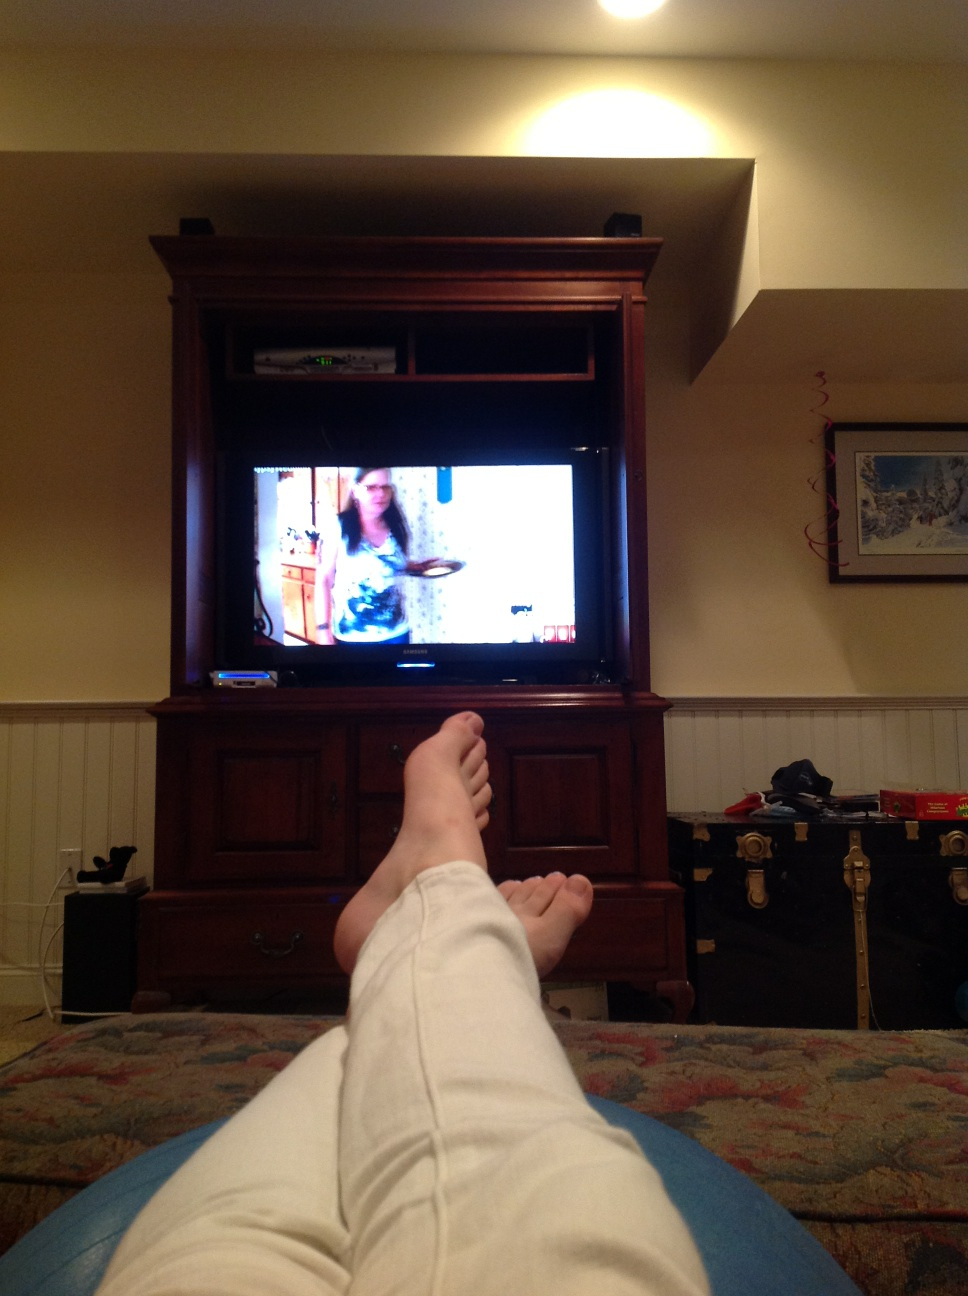Is there anything on the walls? Yes, on the walls, there is some framed artwork to the right of the television, and possibly other decorative items that are not quite discernible because of the picture quality and angle. 